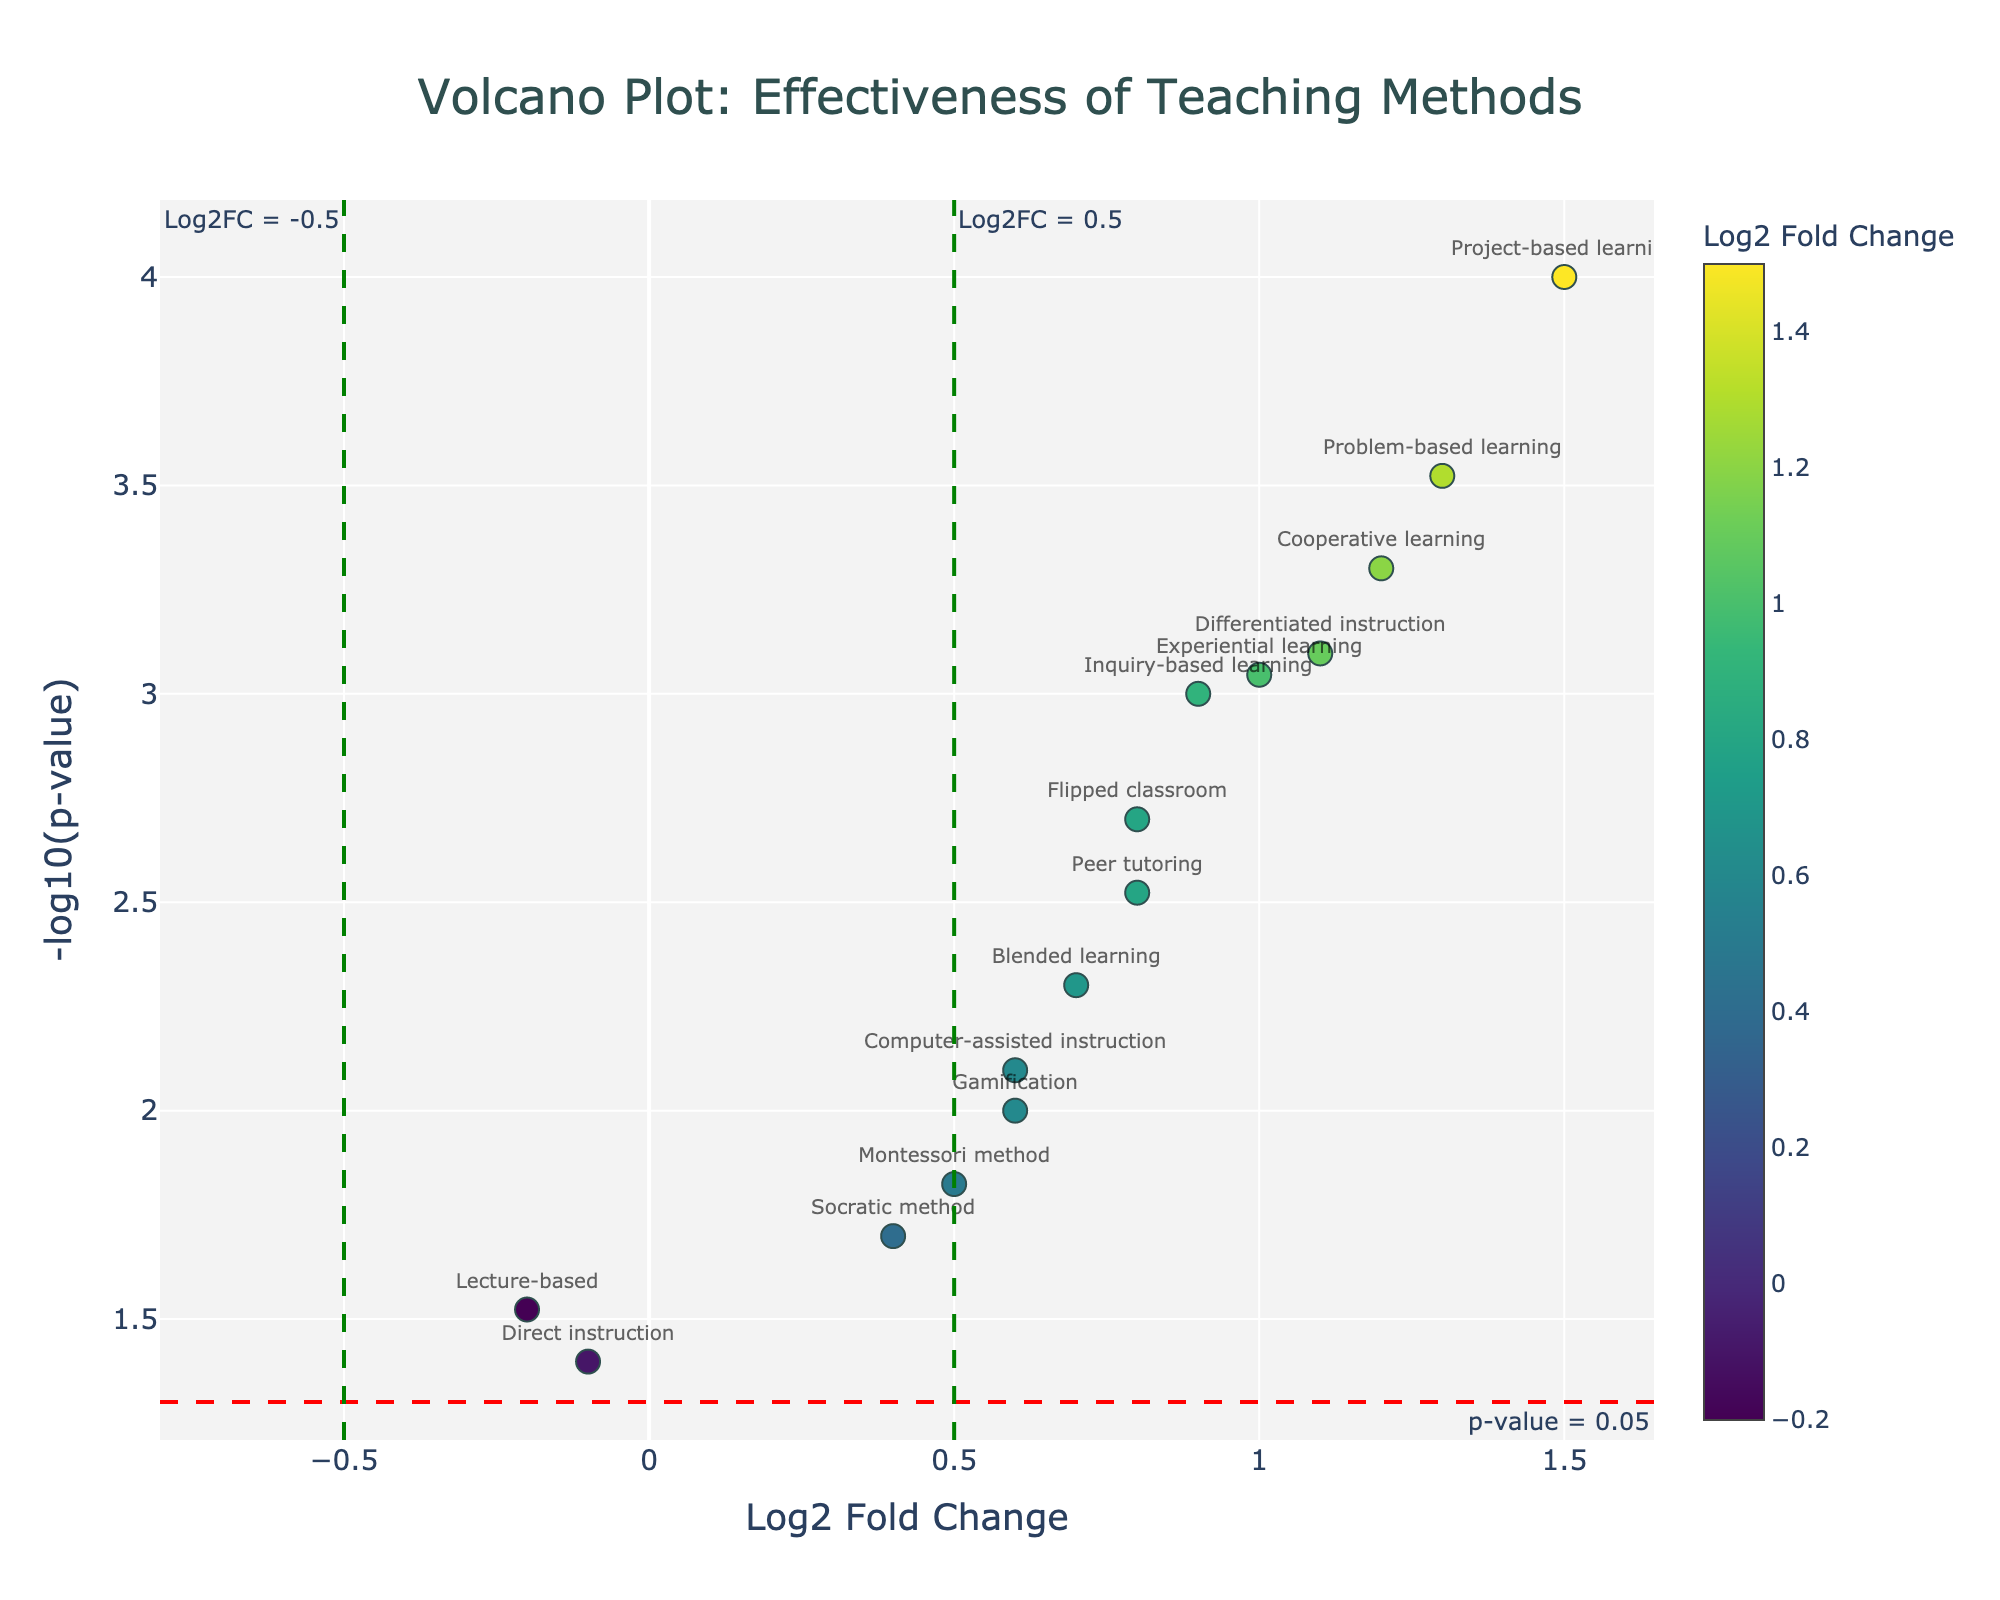What's the title of the figure? The title is usually displayed at the top of the figure and provides a concise description of what the figure represents. In this case, look for the large text at the top-center.
Answer: Volcano Plot: Effectiveness of Teaching Methods What does the x-axis represent? The x-axis is labeled below the horizontal axis, representing the data being measured. Here, the x-axis title indicates it represents the Log2 Fold Change.
Answer: Log2 Fold Change How many teaching methods show significant effectiveness (p-value < 0.05)? To determine the number of data points below the significance threshold, look for points above the red dashed horizontal line at y = -log10(0.05), identifying methods with p-values below 0.05.
Answer: 13 Which teaching method has the highest Log2 Fold Change? Identify the method positioned farthest to the right on the x-axis (positive direction). The associated label with the highest x-value represents the method with the highest Log2 Fold Change.
Answer: Project-based learning Is the gamification method significantly effective based on its p-value? Check the position of the "Gamification" label on the plot. If it is above the red dashed horizontal line at y = -log10(0.05), it indicates significance (p-value < 0.05).
Answer: Yes Which teaching methods have a negative Log2 Fold Change? Identify the methods positioned left of the origin on the x-axis, indicating a negative Log2 Fold Change. The labels in this region represent these methods.
Answer: Lecture-based, Direct instruction Out of 'Flipped classroom' and 'Peer tutoring', which one has a smaller p-value? Compare the vertical positions of the "Flipped classroom" and "Peer tutoring" labels. The method placed higher on the y-axis has a smaller p-value.
Answer: Flipped classroom What's the range of -log10(p-value) in the plot? To find the range, identify the minimum and maximum y-values displayed on the plot, which represent the lowest and highest -log10(p-value) values.
Answer: 1.4 to 4 How does 'Inquiry-based learning' compare to 'Experiential learning' in terms of Log2 Fold Change and p-value? Locate both labels and compare their x-coordinates (Log2 Fold Change) and y-coordinates (-log10(p-value)). Determine which one is higher for each value.
Answer: Inquiry-based learning: Log2FC of 0.9, p-value of 0.001; Experiential learning: Log2FC of 1.0, p-value of 0.0009. Both are effective, with Experiential learning having a higher Log2FC and slightly lower p-value What teaching method has the closest Log2 Fold Change to zero but still significantly affects the test scores? Look for methods closest to the origin (x=0) but positioned above the significance threshold (y > -log10(0.05)).
Answer: Lecture-based 